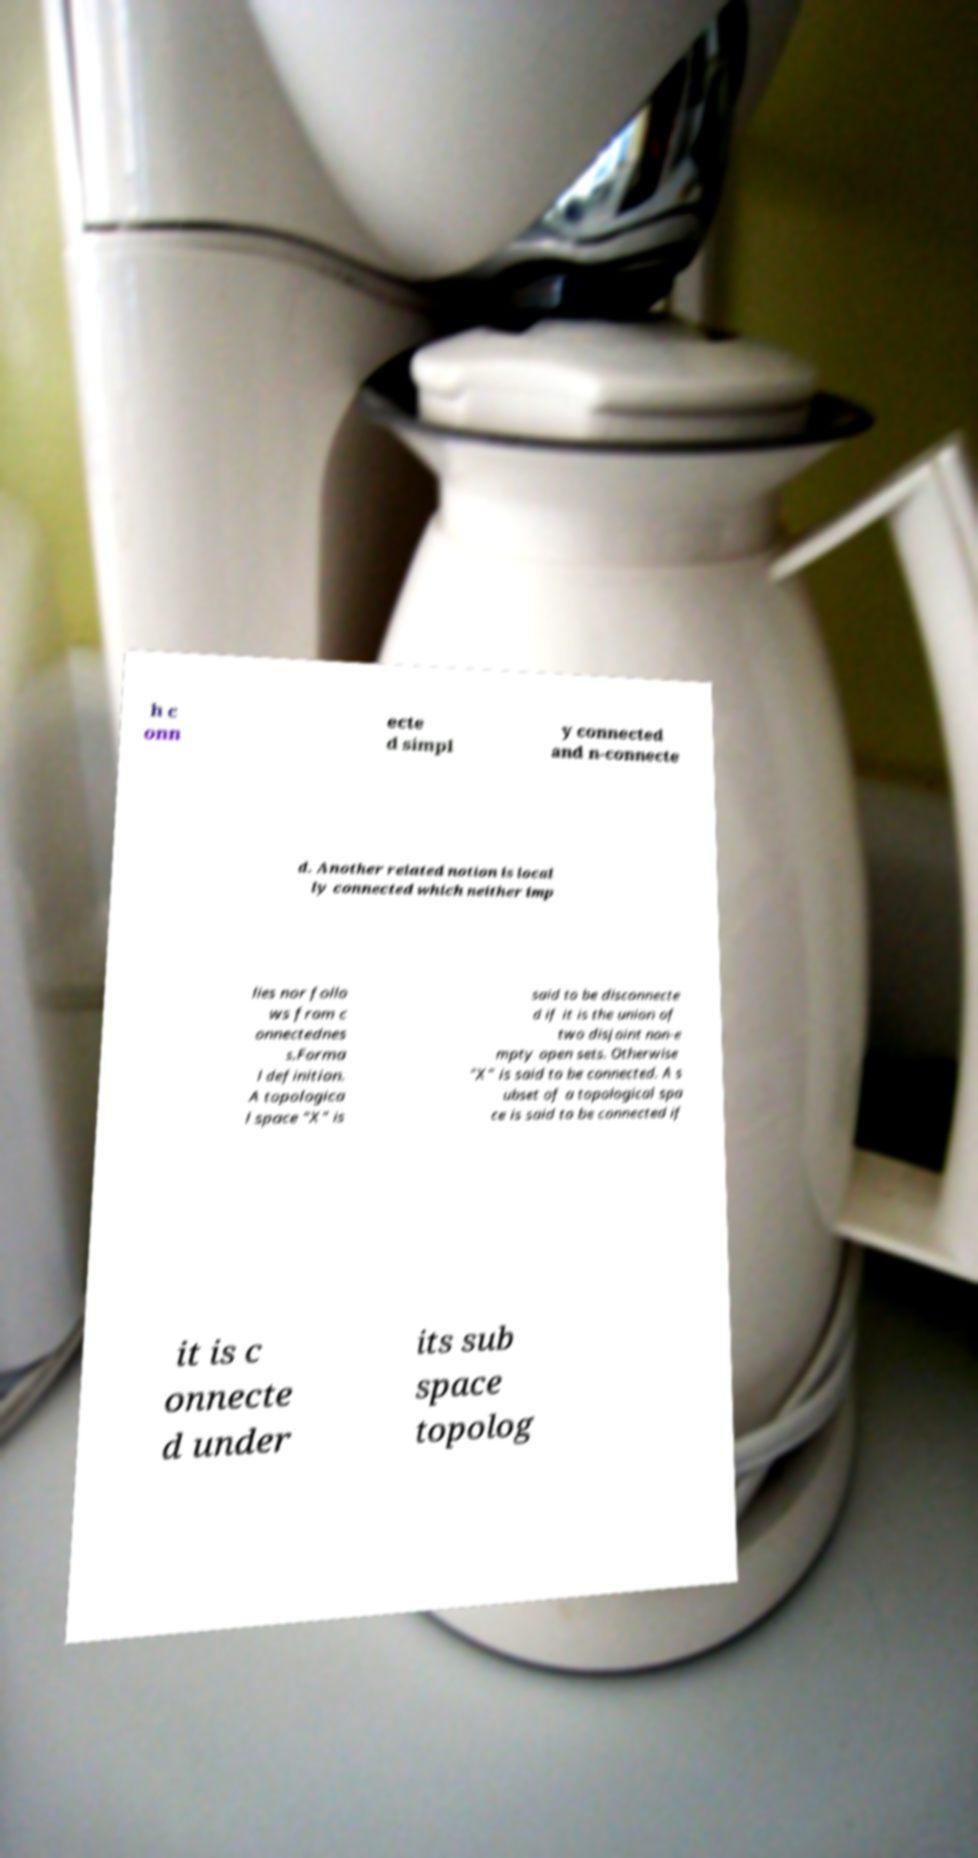Can you read and provide the text displayed in the image?This photo seems to have some interesting text. Can you extract and type it out for me? h c onn ecte d simpl y connected and n-connecte d. Another related notion is local ly connected which neither imp lies nor follo ws from c onnectednes s.Forma l definition. A topologica l space "X" is said to be disconnecte d if it is the union of two disjoint non-e mpty open sets. Otherwise "X" is said to be connected. A s ubset of a topological spa ce is said to be connected if it is c onnecte d under its sub space topolog 